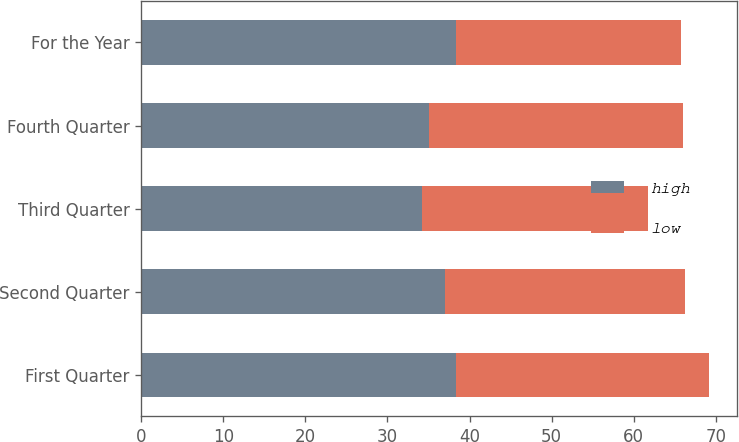Convert chart. <chart><loc_0><loc_0><loc_500><loc_500><stacked_bar_chart><ecel><fcel>First Quarter<fcel>Second Quarter<fcel>Third Quarter<fcel>Fourth Quarter<fcel>For the Year<nl><fcel>high<fcel>38.3<fcel>36.99<fcel>34.24<fcel>35.1<fcel>38.3<nl><fcel>low<fcel>30.87<fcel>29.3<fcel>27.49<fcel>30.92<fcel>27.49<nl></chart> 